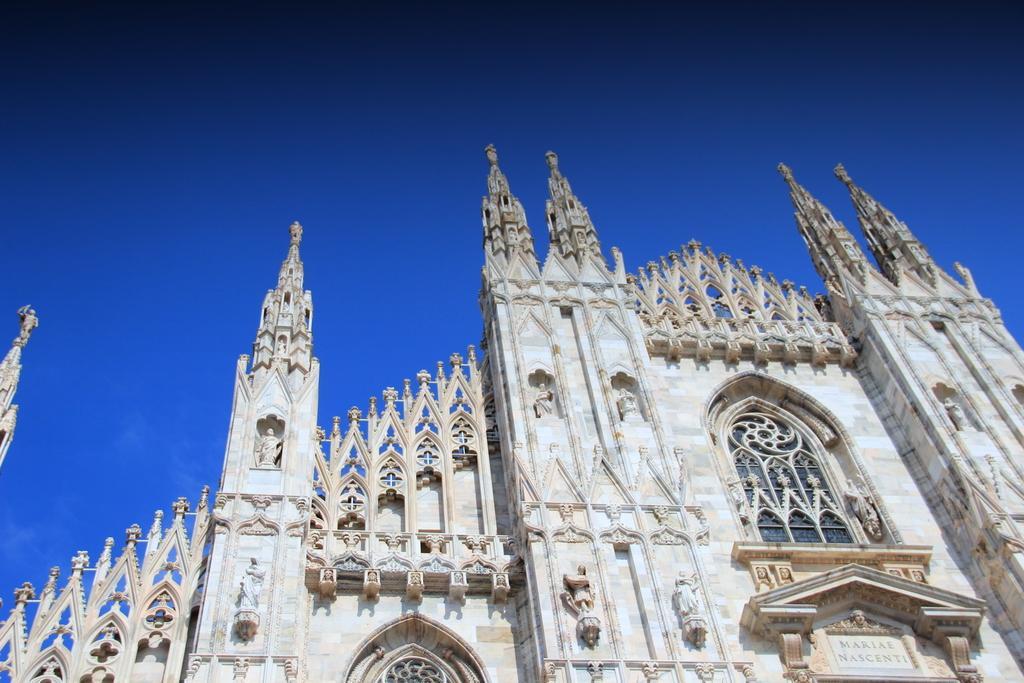Please provide a concise description of this image. in this image there is a castle. 